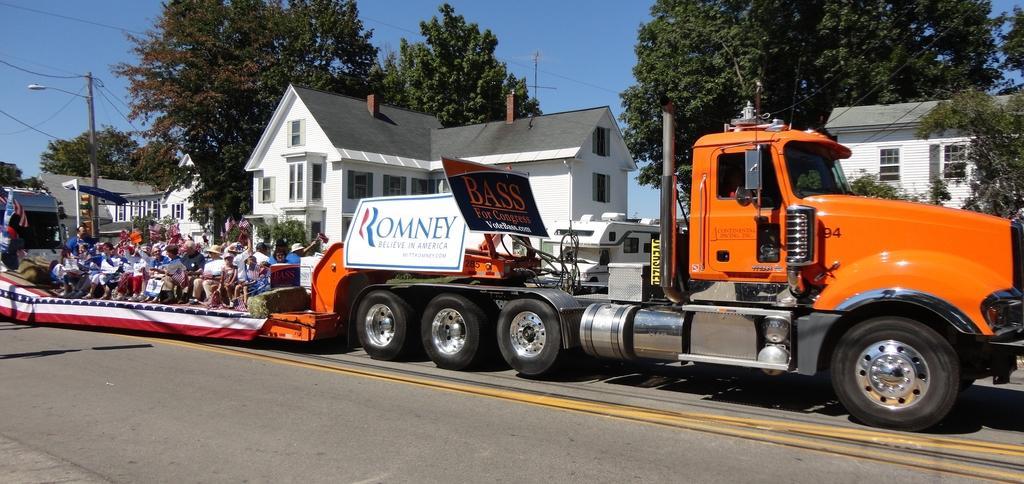How would you summarize this image in a sentence or two? In this image I can see the vehicle on the road. I can see the group of people sitting on the vehicle and there are boards attached to the vehicle. In the background I can see the buildings, poles, many trees and the sky. 